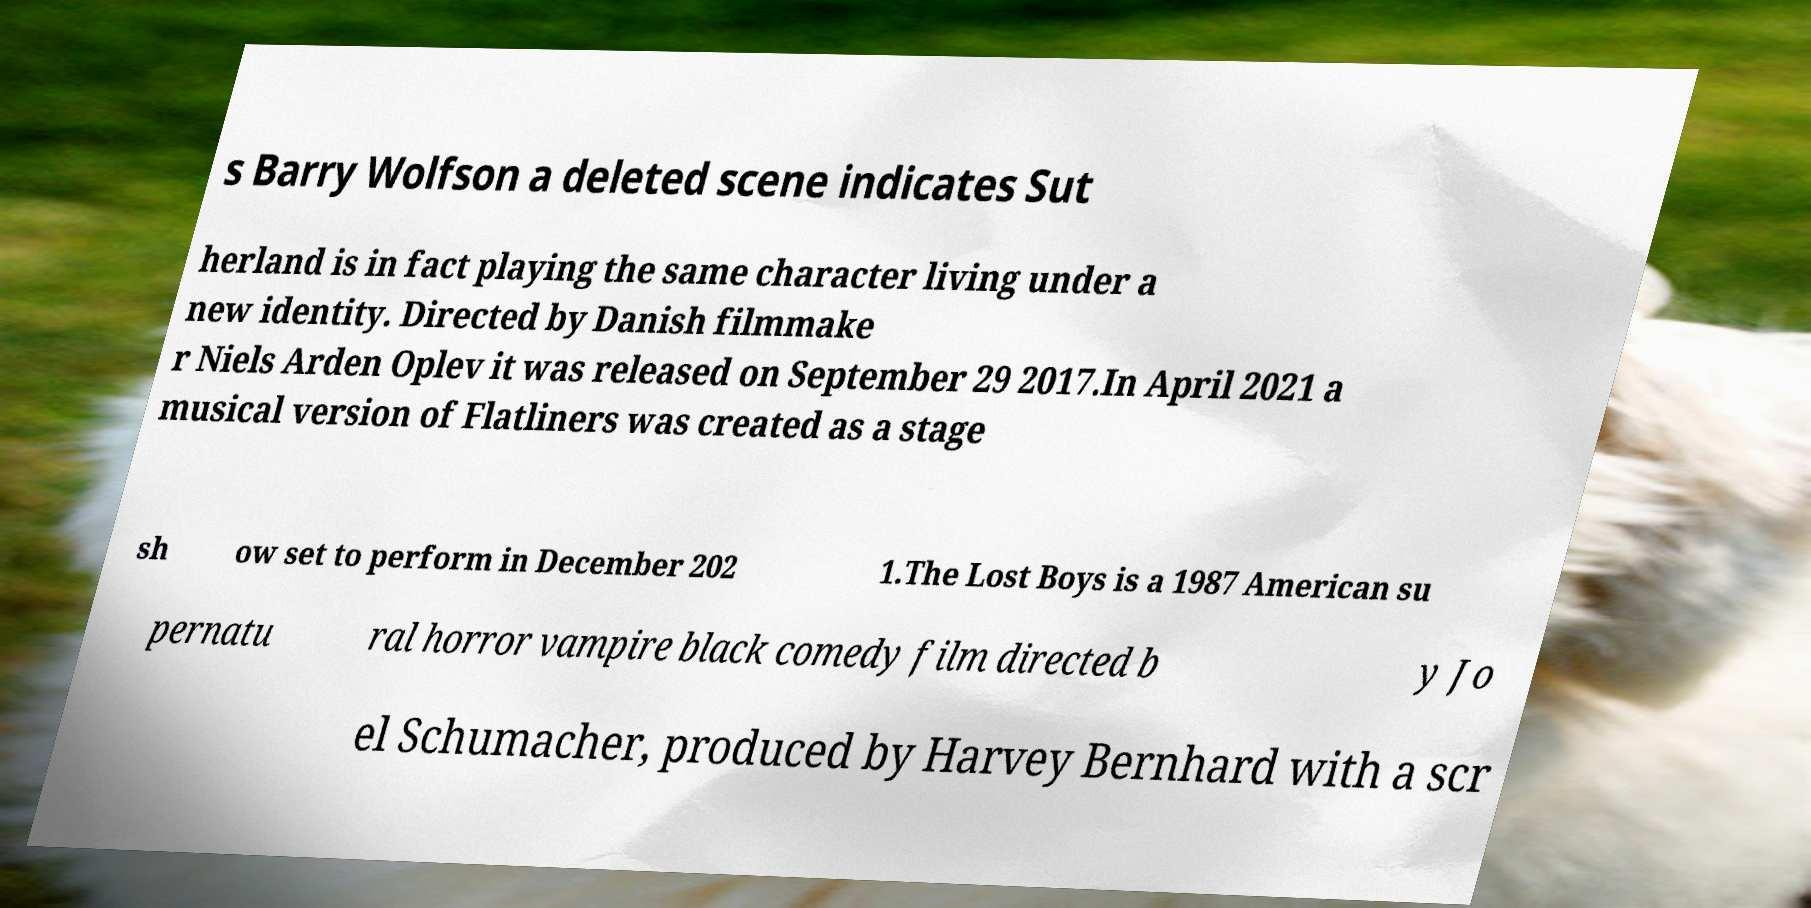There's text embedded in this image that I need extracted. Can you transcribe it verbatim? s Barry Wolfson a deleted scene indicates Sut herland is in fact playing the same character living under a new identity. Directed by Danish filmmake r Niels Arden Oplev it was released on September 29 2017.In April 2021 a musical version of Flatliners was created as a stage sh ow set to perform in December 202 1.The Lost Boys is a 1987 American su pernatu ral horror vampire black comedy film directed b y Jo el Schumacher, produced by Harvey Bernhard with a scr 